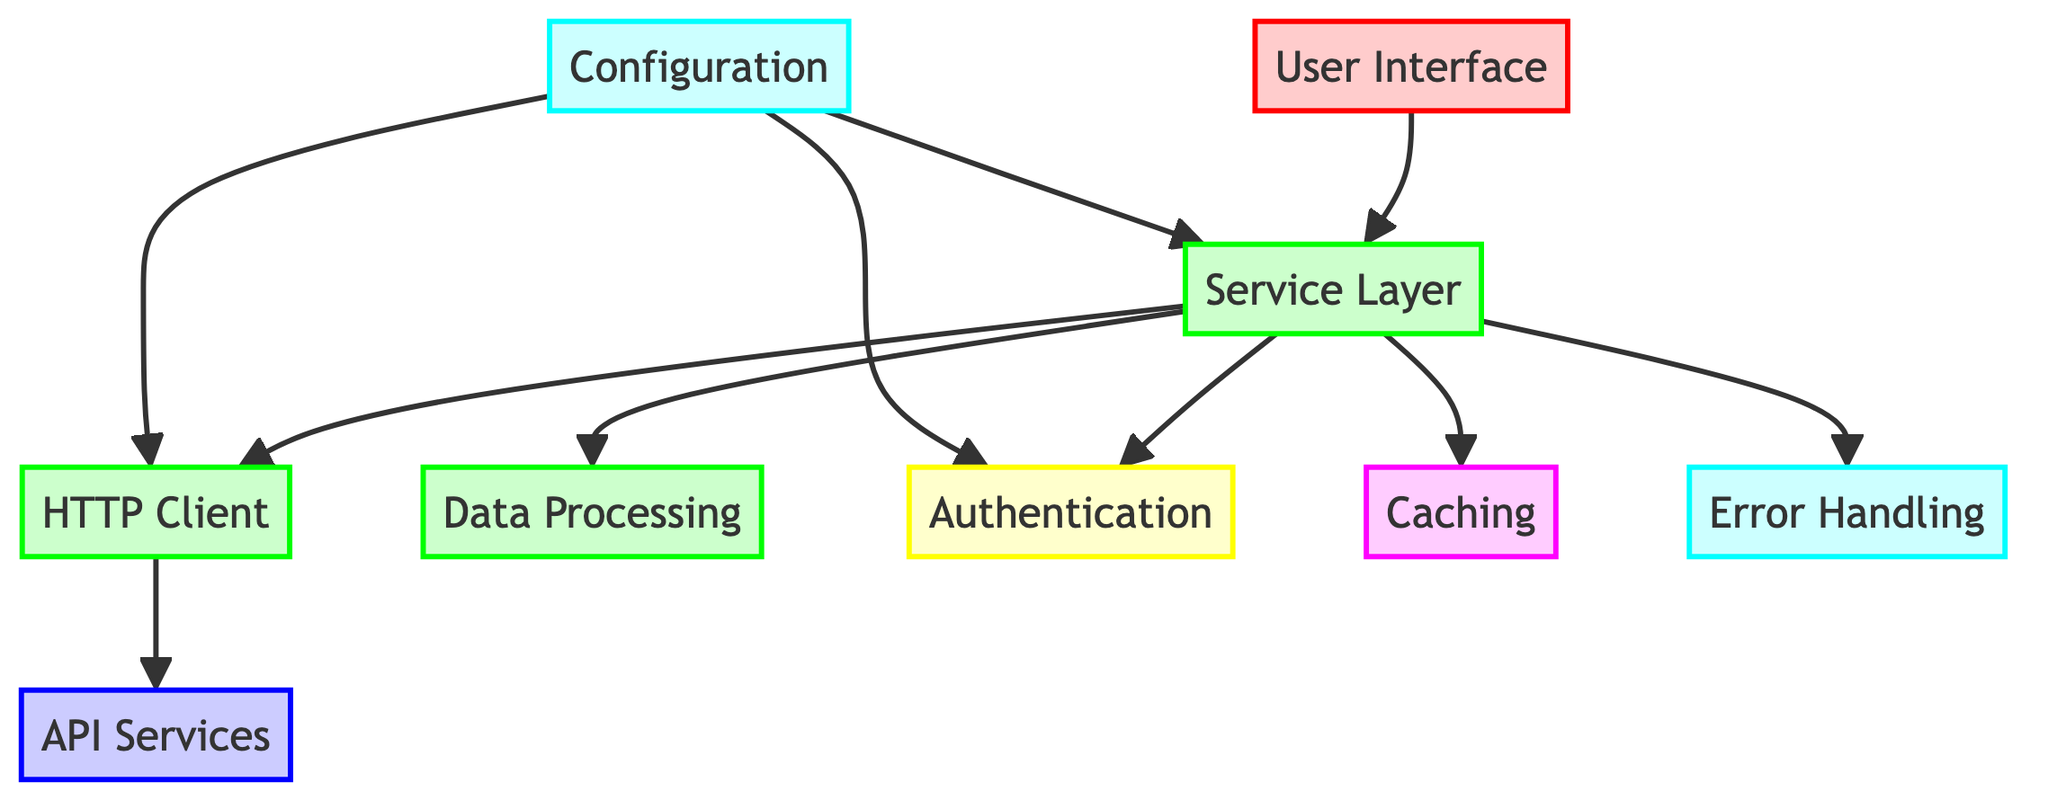what is the type of the User Interface? The diagram classifies the User Interface as a Frontend Component, denoted with a specific color coding and description.
Answer: Frontend Component how many backend components are there? By analyzing the diagram, the backend components include the HTTP Client, Data Processing, and Service Layer. Counting these gives a total of three backend components.
Answer: 3 which component directly interacts with API Services? The HTTP Client is shown to have a direct connection to API Services, indicating that it is responsible for making API requests.
Answer: HTTP Client what type of component is Authentication? The diagram identifies Authentication as a Security Component, categorized accordingly with a specific color and description.
Answer: Security Component what is the purpose of Caching? According to the diagram, Caching's role is to store frequently accessed data to enhance performance by reducing API calls.
Answer: Reduce API calls which component is responsible for error management during API calls? The Error Handling component is detailed in the diagram as managing errors and exceptions that arise during API calls, data processing, and UI updates.
Answer: Error Handling what does the Service Layer coordinate? The Service Layer is described in the diagram as coordinating the communication between the HTTP Client, data processing units, and UI components, thus serving as a mediator.
Answer: Communication coordination how does Configuration interact with other components? The diagram shows Configuration interacting with both the Service Layer and HTTP Client, indicating that it provides necessary settings and credentials they require to operate effectively.
Answer: Provides necessary settings what strategies are mentioned for Caching? The diagram lists In-Memory Cache and Disk Cache as the strategies utilized for Caching, showing both methods available for optimization purposes.
Answer: In-Memory Cache, Disk Cache which component would you consider first for securing API access? Based on the diagram, Authentication is the component focused on managing security measures like API key management and OAuth tokens.
Answer: Authentication 